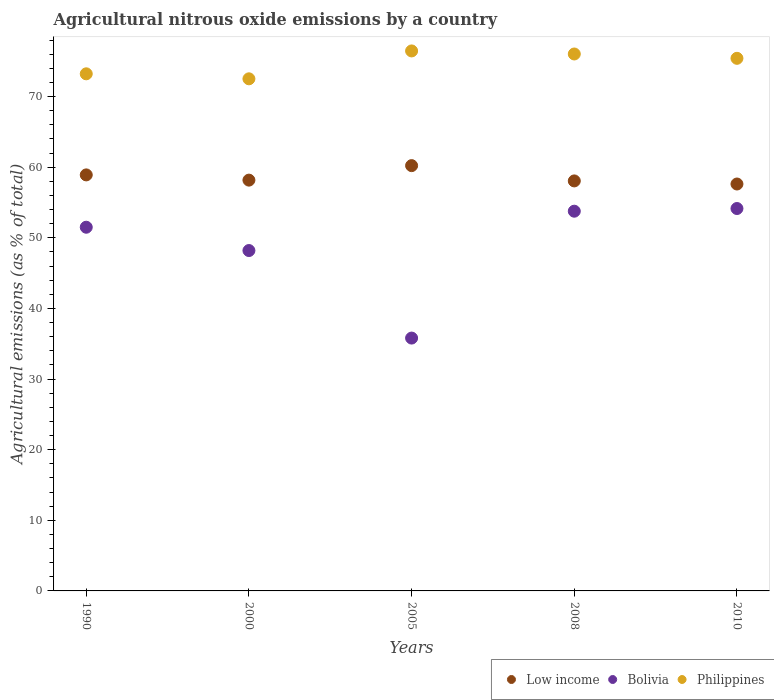How many different coloured dotlines are there?
Ensure brevity in your answer.  3. Is the number of dotlines equal to the number of legend labels?
Provide a succinct answer. Yes. What is the amount of agricultural nitrous oxide emitted in Bolivia in 2005?
Ensure brevity in your answer.  35.8. Across all years, what is the maximum amount of agricultural nitrous oxide emitted in Low income?
Your answer should be compact. 60.22. Across all years, what is the minimum amount of agricultural nitrous oxide emitted in Philippines?
Keep it short and to the point. 72.52. What is the total amount of agricultural nitrous oxide emitted in Bolivia in the graph?
Offer a terse response. 243.43. What is the difference between the amount of agricultural nitrous oxide emitted in Bolivia in 2008 and that in 2010?
Offer a terse response. -0.38. What is the difference between the amount of agricultural nitrous oxide emitted in Bolivia in 2000 and the amount of agricultural nitrous oxide emitted in Low income in 2010?
Make the answer very short. -9.42. What is the average amount of agricultural nitrous oxide emitted in Bolivia per year?
Offer a terse response. 48.69. In the year 2010, what is the difference between the amount of agricultural nitrous oxide emitted in Low income and amount of agricultural nitrous oxide emitted in Philippines?
Provide a short and direct response. -17.8. What is the ratio of the amount of agricultural nitrous oxide emitted in Bolivia in 2005 to that in 2010?
Make the answer very short. 0.66. What is the difference between the highest and the second highest amount of agricultural nitrous oxide emitted in Philippines?
Make the answer very short. 0.43. What is the difference between the highest and the lowest amount of agricultural nitrous oxide emitted in Philippines?
Keep it short and to the point. 3.95. In how many years, is the amount of agricultural nitrous oxide emitted in Bolivia greater than the average amount of agricultural nitrous oxide emitted in Bolivia taken over all years?
Ensure brevity in your answer.  3. Is the sum of the amount of agricultural nitrous oxide emitted in Bolivia in 1990 and 2008 greater than the maximum amount of agricultural nitrous oxide emitted in Low income across all years?
Provide a succinct answer. Yes. Is it the case that in every year, the sum of the amount of agricultural nitrous oxide emitted in Bolivia and amount of agricultural nitrous oxide emitted in Low income  is greater than the amount of agricultural nitrous oxide emitted in Philippines?
Give a very brief answer. Yes. Does the amount of agricultural nitrous oxide emitted in Low income monotonically increase over the years?
Your answer should be compact. No. Is the amount of agricultural nitrous oxide emitted in Philippines strictly greater than the amount of agricultural nitrous oxide emitted in Low income over the years?
Your response must be concise. Yes. How many dotlines are there?
Make the answer very short. 3. How many years are there in the graph?
Ensure brevity in your answer.  5. Does the graph contain grids?
Your answer should be compact. No. What is the title of the graph?
Provide a short and direct response. Agricultural nitrous oxide emissions by a country. What is the label or title of the X-axis?
Ensure brevity in your answer.  Years. What is the label or title of the Y-axis?
Ensure brevity in your answer.  Agricultural emissions (as % of total). What is the Agricultural emissions (as % of total) of Low income in 1990?
Your answer should be compact. 58.91. What is the Agricultural emissions (as % of total) of Bolivia in 1990?
Provide a succinct answer. 51.5. What is the Agricultural emissions (as % of total) of Philippines in 1990?
Your answer should be very brief. 73.22. What is the Agricultural emissions (as % of total) of Low income in 2000?
Your answer should be very brief. 58.17. What is the Agricultural emissions (as % of total) in Bolivia in 2000?
Offer a terse response. 48.2. What is the Agricultural emissions (as % of total) of Philippines in 2000?
Offer a very short reply. 72.52. What is the Agricultural emissions (as % of total) in Low income in 2005?
Make the answer very short. 60.22. What is the Agricultural emissions (as % of total) in Bolivia in 2005?
Offer a terse response. 35.8. What is the Agricultural emissions (as % of total) of Philippines in 2005?
Ensure brevity in your answer.  76.47. What is the Agricultural emissions (as % of total) in Low income in 2008?
Provide a short and direct response. 58.06. What is the Agricultural emissions (as % of total) in Bolivia in 2008?
Keep it short and to the point. 53.77. What is the Agricultural emissions (as % of total) in Philippines in 2008?
Your response must be concise. 76.03. What is the Agricultural emissions (as % of total) in Low income in 2010?
Offer a very short reply. 57.62. What is the Agricultural emissions (as % of total) in Bolivia in 2010?
Provide a succinct answer. 54.15. What is the Agricultural emissions (as % of total) in Philippines in 2010?
Your response must be concise. 75.42. Across all years, what is the maximum Agricultural emissions (as % of total) in Low income?
Provide a short and direct response. 60.22. Across all years, what is the maximum Agricultural emissions (as % of total) of Bolivia?
Keep it short and to the point. 54.15. Across all years, what is the maximum Agricultural emissions (as % of total) of Philippines?
Your response must be concise. 76.47. Across all years, what is the minimum Agricultural emissions (as % of total) of Low income?
Keep it short and to the point. 57.62. Across all years, what is the minimum Agricultural emissions (as % of total) of Bolivia?
Provide a short and direct response. 35.8. Across all years, what is the minimum Agricultural emissions (as % of total) in Philippines?
Give a very brief answer. 72.52. What is the total Agricultural emissions (as % of total) of Low income in the graph?
Your answer should be compact. 292.99. What is the total Agricultural emissions (as % of total) in Bolivia in the graph?
Offer a very short reply. 243.43. What is the total Agricultural emissions (as % of total) in Philippines in the graph?
Ensure brevity in your answer.  373.66. What is the difference between the Agricultural emissions (as % of total) of Low income in 1990 and that in 2000?
Your answer should be compact. 0.74. What is the difference between the Agricultural emissions (as % of total) of Bolivia in 1990 and that in 2000?
Your answer should be compact. 3.3. What is the difference between the Agricultural emissions (as % of total) in Philippines in 1990 and that in 2000?
Make the answer very short. 0.71. What is the difference between the Agricultural emissions (as % of total) of Low income in 1990 and that in 2005?
Your answer should be very brief. -1.31. What is the difference between the Agricultural emissions (as % of total) in Bolivia in 1990 and that in 2005?
Your answer should be compact. 15.7. What is the difference between the Agricultural emissions (as % of total) of Philippines in 1990 and that in 2005?
Make the answer very short. -3.24. What is the difference between the Agricultural emissions (as % of total) of Low income in 1990 and that in 2008?
Your response must be concise. 0.85. What is the difference between the Agricultural emissions (as % of total) in Bolivia in 1990 and that in 2008?
Provide a short and direct response. -2.27. What is the difference between the Agricultural emissions (as % of total) of Philippines in 1990 and that in 2008?
Provide a short and direct response. -2.81. What is the difference between the Agricultural emissions (as % of total) of Low income in 1990 and that in 2010?
Offer a very short reply. 1.29. What is the difference between the Agricultural emissions (as % of total) in Bolivia in 1990 and that in 2010?
Provide a short and direct response. -2.65. What is the difference between the Agricultural emissions (as % of total) of Philippines in 1990 and that in 2010?
Provide a short and direct response. -2.2. What is the difference between the Agricultural emissions (as % of total) in Low income in 2000 and that in 2005?
Provide a short and direct response. -2.05. What is the difference between the Agricultural emissions (as % of total) of Bolivia in 2000 and that in 2005?
Keep it short and to the point. 12.4. What is the difference between the Agricultural emissions (as % of total) of Philippines in 2000 and that in 2005?
Give a very brief answer. -3.95. What is the difference between the Agricultural emissions (as % of total) of Low income in 2000 and that in 2008?
Your answer should be compact. 0.11. What is the difference between the Agricultural emissions (as % of total) of Bolivia in 2000 and that in 2008?
Provide a succinct answer. -5.57. What is the difference between the Agricultural emissions (as % of total) of Philippines in 2000 and that in 2008?
Your answer should be compact. -3.52. What is the difference between the Agricultural emissions (as % of total) in Low income in 2000 and that in 2010?
Give a very brief answer. 0.55. What is the difference between the Agricultural emissions (as % of total) in Bolivia in 2000 and that in 2010?
Keep it short and to the point. -5.95. What is the difference between the Agricultural emissions (as % of total) of Philippines in 2000 and that in 2010?
Keep it short and to the point. -2.9. What is the difference between the Agricultural emissions (as % of total) of Low income in 2005 and that in 2008?
Ensure brevity in your answer.  2.16. What is the difference between the Agricultural emissions (as % of total) in Bolivia in 2005 and that in 2008?
Keep it short and to the point. -17.97. What is the difference between the Agricultural emissions (as % of total) in Philippines in 2005 and that in 2008?
Make the answer very short. 0.43. What is the difference between the Agricultural emissions (as % of total) in Low income in 2005 and that in 2010?
Offer a terse response. 2.6. What is the difference between the Agricultural emissions (as % of total) in Bolivia in 2005 and that in 2010?
Ensure brevity in your answer.  -18.35. What is the difference between the Agricultural emissions (as % of total) in Philippines in 2005 and that in 2010?
Your response must be concise. 1.05. What is the difference between the Agricultural emissions (as % of total) of Low income in 2008 and that in 2010?
Provide a succinct answer. 0.44. What is the difference between the Agricultural emissions (as % of total) in Bolivia in 2008 and that in 2010?
Make the answer very short. -0.38. What is the difference between the Agricultural emissions (as % of total) in Philippines in 2008 and that in 2010?
Your answer should be compact. 0.61. What is the difference between the Agricultural emissions (as % of total) in Low income in 1990 and the Agricultural emissions (as % of total) in Bolivia in 2000?
Your answer should be very brief. 10.71. What is the difference between the Agricultural emissions (as % of total) in Low income in 1990 and the Agricultural emissions (as % of total) in Philippines in 2000?
Provide a succinct answer. -13.61. What is the difference between the Agricultural emissions (as % of total) in Bolivia in 1990 and the Agricultural emissions (as % of total) in Philippines in 2000?
Ensure brevity in your answer.  -21.02. What is the difference between the Agricultural emissions (as % of total) of Low income in 1990 and the Agricultural emissions (as % of total) of Bolivia in 2005?
Make the answer very short. 23.11. What is the difference between the Agricultural emissions (as % of total) in Low income in 1990 and the Agricultural emissions (as % of total) in Philippines in 2005?
Provide a succinct answer. -17.55. What is the difference between the Agricultural emissions (as % of total) of Bolivia in 1990 and the Agricultural emissions (as % of total) of Philippines in 2005?
Make the answer very short. -24.96. What is the difference between the Agricultural emissions (as % of total) in Low income in 1990 and the Agricultural emissions (as % of total) in Bolivia in 2008?
Provide a succinct answer. 5.14. What is the difference between the Agricultural emissions (as % of total) in Low income in 1990 and the Agricultural emissions (as % of total) in Philippines in 2008?
Ensure brevity in your answer.  -17.12. What is the difference between the Agricultural emissions (as % of total) of Bolivia in 1990 and the Agricultural emissions (as % of total) of Philippines in 2008?
Ensure brevity in your answer.  -24.53. What is the difference between the Agricultural emissions (as % of total) of Low income in 1990 and the Agricultural emissions (as % of total) of Bolivia in 2010?
Your answer should be compact. 4.76. What is the difference between the Agricultural emissions (as % of total) of Low income in 1990 and the Agricultural emissions (as % of total) of Philippines in 2010?
Offer a very short reply. -16.51. What is the difference between the Agricultural emissions (as % of total) of Bolivia in 1990 and the Agricultural emissions (as % of total) of Philippines in 2010?
Give a very brief answer. -23.92. What is the difference between the Agricultural emissions (as % of total) in Low income in 2000 and the Agricultural emissions (as % of total) in Bolivia in 2005?
Ensure brevity in your answer.  22.37. What is the difference between the Agricultural emissions (as % of total) in Low income in 2000 and the Agricultural emissions (as % of total) in Philippines in 2005?
Provide a short and direct response. -18.29. What is the difference between the Agricultural emissions (as % of total) of Bolivia in 2000 and the Agricultural emissions (as % of total) of Philippines in 2005?
Your response must be concise. -28.27. What is the difference between the Agricultural emissions (as % of total) of Low income in 2000 and the Agricultural emissions (as % of total) of Bolivia in 2008?
Your answer should be compact. 4.4. What is the difference between the Agricultural emissions (as % of total) of Low income in 2000 and the Agricultural emissions (as % of total) of Philippines in 2008?
Provide a succinct answer. -17.86. What is the difference between the Agricultural emissions (as % of total) in Bolivia in 2000 and the Agricultural emissions (as % of total) in Philippines in 2008?
Provide a succinct answer. -27.83. What is the difference between the Agricultural emissions (as % of total) in Low income in 2000 and the Agricultural emissions (as % of total) in Bolivia in 2010?
Offer a terse response. 4.02. What is the difference between the Agricultural emissions (as % of total) of Low income in 2000 and the Agricultural emissions (as % of total) of Philippines in 2010?
Give a very brief answer. -17.25. What is the difference between the Agricultural emissions (as % of total) of Bolivia in 2000 and the Agricultural emissions (as % of total) of Philippines in 2010?
Offer a very short reply. -27.22. What is the difference between the Agricultural emissions (as % of total) of Low income in 2005 and the Agricultural emissions (as % of total) of Bolivia in 2008?
Ensure brevity in your answer.  6.45. What is the difference between the Agricultural emissions (as % of total) of Low income in 2005 and the Agricultural emissions (as % of total) of Philippines in 2008?
Provide a short and direct response. -15.81. What is the difference between the Agricultural emissions (as % of total) of Bolivia in 2005 and the Agricultural emissions (as % of total) of Philippines in 2008?
Keep it short and to the point. -40.23. What is the difference between the Agricultural emissions (as % of total) in Low income in 2005 and the Agricultural emissions (as % of total) in Bolivia in 2010?
Provide a succinct answer. 6.07. What is the difference between the Agricultural emissions (as % of total) of Low income in 2005 and the Agricultural emissions (as % of total) of Philippines in 2010?
Your answer should be compact. -15.2. What is the difference between the Agricultural emissions (as % of total) in Bolivia in 2005 and the Agricultural emissions (as % of total) in Philippines in 2010?
Your answer should be compact. -39.62. What is the difference between the Agricultural emissions (as % of total) in Low income in 2008 and the Agricultural emissions (as % of total) in Bolivia in 2010?
Ensure brevity in your answer.  3.91. What is the difference between the Agricultural emissions (as % of total) in Low income in 2008 and the Agricultural emissions (as % of total) in Philippines in 2010?
Your response must be concise. -17.36. What is the difference between the Agricultural emissions (as % of total) in Bolivia in 2008 and the Agricultural emissions (as % of total) in Philippines in 2010?
Your response must be concise. -21.65. What is the average Agricultural emissions (as % of total) of Low income per year?
Your response must be concise. 58.6. What is the average Agricultural emissions (as % of total) of Bolivia per year?
Your answer should be compact. 48.69. What is the average Agricultural emissions (as % of total) in Philippines per year?
Give a very brief answer. 74.73. In the year 1990, what is the difference between the Agricultural emissions (as % of total) in Low income and Agricultural emissions (as % of total) in Bolivia?
Provide a succinct answer. 7.41. In the year 1990, what is the difference between the Agricultural emissions (as % of total) of Low income and Agricultural emissions (as % of total) of Philippines?
Offer a terse response. -14.31. In the year 1990, what is the difference between the Agricultural emissions (as % of total) in Bolivia and Agricultural emissions (as % of total) in Philippines?
Keep it short and to the point. -21.72. In the year 2000, what is the difference between the Agricultural emissions (as % of total) in Low income and Agricultural emissions (as % of total) in Bolivia?
Make the answer very short. 9.97. In the year 2000, what is the difference between the Agricultural emissions (as % of total) of Low income and Agricultural emissions (as % of total) of Philippines?
Provide a short and direct response. -14.35. In the year 2000, what is the difference between the Agricultural emissions (as % of total) of Bolivia and Agricultural emissions (as % of total) of Philippines?
Offer a very short reply. -24.32. In the year 2005, what is the difference between the Agricultural emissions (as % of total) of Low income and Agricultural emissions (as % of total) of Bolivia?
Offer a very short reply. 24.42. In the year 2005, what is the difference between the Agricultural emissions (as % of total) in Low income and Agricultural emissions (as % of total) in Philippines?
Your answer should be very brief. -16.24. In the year 2005, what is the difference between the Agricultural emissions (as % of total) in Bolivia and Agricultural emissions (as % of total) in Philippines?
Ensure brevity in your answer.  -40.66. In the year 2008, what is the difference between the Agricultural emissions (as % of total) in Low income and Agricultural emissions (as % of total) in Bolivia?
Provide a short and direct response. 4.29. In the year 2008, what is the difference between the Agricultural emissions (as % of total) of Low income and Agricultural emissions (as % of total) of Philippines?
Provide a short and direct response. -17.97. In the year 2008, what is the difference between the Agricultural emissions (as % of total) of Bolivia and Agricultural emissions (as % of total) of Philippines?
Give a very brief answer. -22.26. In the year 2010, what is the difference between the Agricultural emissions (as % of total) in Low income and Agricultural emissions (as % of total) in Bolivia?
Provide a short and direct response. 3.47. In the year 2010, what is the difference between the Agricultural emissions (as % of total) of Low income and Agricultural emissions (as % of total) of Philippines?
Keep it short and to the point. -17.8. In the year 2010, what is the difference between the Agricultural emissions (as % of total) in Bolivia and Agricultural emissions (as % of total) in Philippines?
Ensure brevity in your answer.  -21.27. What is the ratio of the Agricultural emissions (as % of total) in Low income in 1990 to that in 2000?
Offer a terse response. 1.01. What is the ratio of the Agricultural emissions (as % of total) of Bolivia in 1990 to that in 2000?
Your response must be concise. 1.07. What is the ratio of the Agricultural emissions (as % of total) in Philippines in 1990 to that in 2000?
Make the answer very short. 1.01. What is the ratio of the Agricultural emissions (as % of total) in Low income in 1990 to that in 2005?
Ensure brevity in your answer.  0.98. What is the ratio of the Agricultural emissions (as % of total) of Bolivia in 1990 to that in 2005?
Offer a very short reply. 1.44. What is the ratio of the Agricultural emissions (as % of total) of Philippines in 1990 to that in 2005?
Provide a short and direct response. 0.96. What is the ratio of the Agricultural emissions (as % of total) of Low income in 1990 to that in 2008?
Give a very brief answer. 1.01. What is the ratio of the Agricultural emissions (as % of total) in Bolivia in 1990 to that in 2008?
Give a very brief answer. 0.96. What is the ratio of the Agricultural emissions (as % of total) in Philippines in 1990 to that in 2008?
Keep it short and to the point. 0.96. What is the ratio of the Agricultural emissions (as % of total) in Low income in 1990 to that in 2010?
Make the answer very short. 1.02. What is the ratio of the Agricultural emissions (as % of total) of Bolivia in 1990 to that in 2010?
Ensure brevity in your answer.  0.95. What is the ratio of the Agricultural emissions (as % of total) of Philippines in 1990 to that in 2010?
Give a very brief answer. 0.97. What is the ratio of the Agricultural emissions (as % of total) in Low income in 2000 to that in 2005?
Your answer should be compact. 0.97. What is the ratio of the Agricultural emissions (as % of total) of Bolivia in 2000 to that in 2005?
Keep it short and to the point. 1.35. What is the ratio of the Agricultural emissions (as % of total) of Philippines in 2000 to that in 2005?
Give a very brief answer. 0.95. What is the ratio of the Agricultural emissions (as % of total) in Low income in 2000 to that in 2008?
Your answer should be compact. 1. What is the ratio of the Agricultural emissions (as % of total) of Bolivia in 2000 to that in 2008?
Give a very brief answer. 0.9. What is the ratio of the Agricultural emissions (as % of total) in Philippines in 2000 to that in 2008?
Make the answer very short. 0.95. What is the ratio of the Agricultural emissions (as % of total) in Low income in 2000 to that in 2010?
Provide a succinct answer. 1.01. What is the ratio of the Agricultural emissions (as % of total) in Bolivia in 2000 to that in 2010?
Provide a short and direct response. 0.89. What is the ratio of the Agricultural emissions (as % of total) of Philippines in 2000 to that in 2010?
Offer a very short reply. 0.96. What is the ratio of the Agricultural emissions (as % of total) in Low income in 2005 to that in 2008?
Provide a succinct answer. 1.04. What is the ratio of the Agricultural emissions (as % of total) of Bolivia in 2005 to that in 2008?
Provide a short and direct response. 0.67. What is the ratio of the Agricultural emissions (as % of total) of Low income in 2005 to that in 2010?
Ensure brevity in your answer.  1.05. What is the ratio of the Agricultural emissions (as % of total) of Bolivia in 2005 to that in 2010?
Ensure brevity in your answer.  0.66. What is the ratio of the Agricultural emissions (as % of total) in Philippines in 2005 to that in 2010?
Offer a terse response. 1.01. What is the ratio of the Agricultural emissions (as % of total) of Low income in 2008 to that in 2010?
Provide a succinct answer. 1.01. What is the difference between the highest and the second highest Agricultural emissions (as % of total) of Low income?
Give a very brief answer. 1.31. What is the difference between the highest and the second highest Agricultural emissions (as % of total) of Bolivia?
Your answer should be compact. 0.38. What is the difference between the highest and the second highest Agricultural emissions (as % of total) in Philippines?
Give a very brief answer. 0.43. What is the difference between the highest and the lowest Agricultural emissions (as % of total) of Low income?
Your response must be concise. 2.6. What is the difference between the highest and the lowest Agricultural emissions (as % of total) in Bolivia?
Make the answer very short. 18.35. What is the difference between the highest and the lowest Agricultural emissions (as % of total) in Philippines?
Offer a terse response. 3.95. 